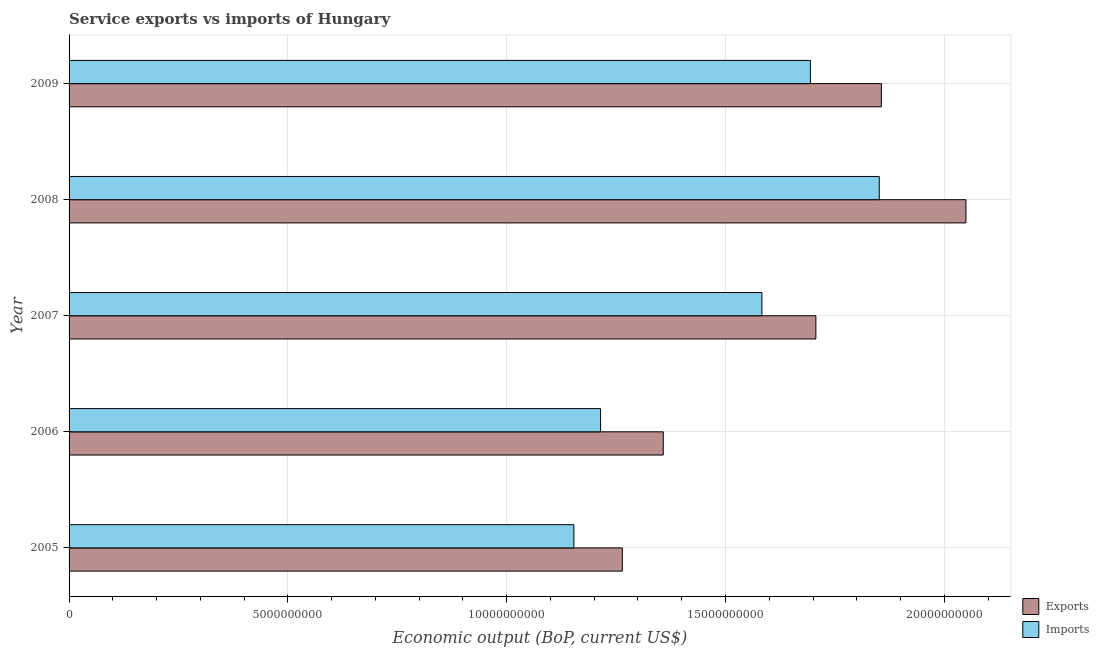How many groups of bars are there?
Give a very brief answer. 5. Are the number of bars per tick equal to the number of legend labels?
Offer a terse response. Yes. Are the number of bars on each tick of the Y-axis equal?
Your response must be concise. Yes. What is the label of the 1st group of bars from the top?
Ensure brevity in your answer.  2009. What is the amount of service imports in 2008?
Your answer should be compact. 1.85e+1. Across all years, what is the maximum amount of service imports?
Your answer should be very brief. 1.85e+1. Across all years, what is the minimum amount of service exports?
Offer a terse response. 1.26e+1. In which year was the amount of service imports maximum?
Provide a short and direct response. 2008. In which year was the amount of service exports minimum?
Ensure brevity in your answer.  2005. What is the total amount of service exports in the graph?
Your response must be concise. 8.23e+1. What is the difference between the amount of service imports in 2007 and that in 2009?
Your answer should be compact. -1.11e+09. What is the difference between the amount of service imports in 2009 and the amount of service exports in 2005?
Your answer should be compact. 4.30e+09. What is the average amount of service exports per year?
Your response must be concise. 1.65e+1. In the year 2007, what is the difference between the amount of service imports and amount of service exports?
Make the answer very short. -1.23e+09. What is the ratio of the amount of service imports in 2006 to that in 2008?
Your answer should be very brief. 0.66. Is the amount of service imports in 2006 less than that in 2009?
Keep it short and to the point. Yes. What is the difference between the highest and the second highest amount of service imports?
Provide a succinct answer. 1.57e+09. What is the difference between the highest and the lowest amount of service exports?
Provide a short and direct response. 7.85e+09. In how many years, is the amount of service exports greater than the average amount of service exports taken over all years?
Provide a short and direct response. 3. Is the sum of the amount of service imports in 2006 and 2008 greater than the maximum amount of service exports across all years?
Offer a very short reply. Yes. What does the 1st bar from the top in 2009 represents?
Keep it short and to the point. Imports. What does the 2nd bar from the bottom in 2006 represents?
Offer a terse response. Imports. How many bars are there?
Offer a terse response. 10. What is the difference between two consecutive major ticks on the X-axis?
Ensure brevity in your answer.  5.00e+09. Are the values on the major ticks of X-axis written in scientific E-notation?
Offer a very short reply. No. Does the graph contain any zero values?
Offer a terse response. No. Does the graph contain grids?
Offer a terse response. Yes. What is the title of the graph?
Your answer should be very brief. Service exports vs imports of Hungary. What is the label or title of the X-axis?
Make the answer very short. Economic output (BoP, current US$). What is the label or title of the Y-axis?
Your response must be concise. Year. What is the Economic output (BoP, current US$) of Exports in 2005?
Your answer should be very brief. 1.26e+1. What is the Economic output (BoP, current US$) in Imports in 2005?
Offer a terse response. 1.15e+1. What is the Economic output (BoP, current US$) of Exports in 2006?
Make the answer very short. 1.36e+1. What is the Economic output (BoP, current US$) in Imports in 2006?
Make the answer very short. 1.21e+1. What is the Economic output (BoP, current US$) in Exports in 2007?
Offer a very short reply. 1.71e+1. What is the Economic output (BoP, current US$) of Imports in 2007?
Offer a very short reply. 1.58e+1. What is the Economic output (BoP, current US$) in Exports in 2008?
Give a very brief answer. 2.05e+1. What is the Economic output (BoP, current US$) in Imports in 2008?
Your answer should be compact. 1.85e+1. What is the Economic output (BoP, current US$) of Exports in 2009?
Provide a short and direct response. 1.86e+1. What is the Economic output (BoP, current US$) of Imports in 2009?
Keep it short and to the point. 1.69e+1. Across all years, what is the maximum Economic output (BoP, current US$) of Exports?
Provide a succinct answer. 2.05e+1. Across all years, what is the maximum Economic output (BoP, current US$) in Imports?
Your answer should be compact. 1.85e+1. Across all years, what is the minimum Economic output (BoP, current US$) of Exports?
Provide a succinct answer. 1.26e+1. Across all years, what is the minimum Economic output (BoP, current US$) in Imports?
Offer a terse response. 1.15e+1. What is the total Economic output (BoP, current US$) in Exports in the graph?
Keep it short and to the point. 8.23e+1. What is the total Economic output (BoP, current US$) in Imports in the graph?
Offer a terse response. 7.50e+1. What is the difference between the Economic output (BoP, current US$) in Exports in 2005 and that in 2006?
Ensure brevity in your answer.  -9.35e+08. What is the difference between the Economic output (BoP, current US$) in Imports in 2005 and that in 2006?
Offer a very short reply. -6.10e+08. What is the difference between the Economic output (BoP, current US$) in Exports in 2005 and that in 2007?
Offer a terse response. -4.42e+09. What is the difference between the Economic output (BoP, current US$) of Imports in 2005 and that in 2007?
Provide a short and direct response. -4.30e+09. What is the difference between the Economic output (BoP, current US$) in Exports in 2005 and that in 2008?
Provide a short and direct response. -7.85e+09. What is the difference between the Economic output (BoP, current US$) in Imports in 2005 and that in 2008?
Your response must be concise. -6.98e+09. What is the difference between the Economic output (BoP, current US$) of Exports in 2005 and that in 2009?
Offer a terse response. -5.92e+09. What is the difference between the Economic output (BoP, current US$) in Imports in 2005 and that in 2009?
Your answer should be compact. -5.40e+09. What is the difference between the Economic output (BoP, current US$) of Exports in 2006 and that in 2007?
Your answer should be compact. -3.49e+09. What is the difference between the Economic output (BoP, current US$) of Imports in 2006 and that in 2007?
Provide a succinct answer. -3.69e+09. What is the difference between the Economic output (BoP, current US$) in Exports in 2006 and that in 2008?
Ensure brevity in your answer.  -6.92e+09. What is the difference between the Economic output (BoP, current US$) in Imports in 2006 and that in 2008?
Make the answer very short. -6.37e+09. What is the difference between the Economic output (BoP, current US$) of Exports in 2006 and that in 2009?
Keep it short and to the point. -4.98e+09. What is the difference between the Economic output (BoP, current US$) of Imports in 2006 and that in 2009?
Your answer should be compact. -4.79e+09. What is the difference between the Economic output (BoP, current US$) in Exports in 2007 and that in 2008?
Provide a short and direct response. -3.43e+09. What is the difference between the Economic output (BoP, current US$) of Imports in 2007 and that in 2008?
Ensure brevity in your answer.  -2.68e+09. What is the difference between the Economic output (BoP, current US$) of Exports in 2007 and that in 2009?
Provide a succinct answer. -1.50e+09. What is the difference between the Economic output (BoP, current US$) of Imports in 2007 and that in 2009?
Your answer should be compact. -1.11e+09. What is the difference between the Economic output (BoP, current US$) in Exports in 2008 and that in 2009?
Your answer should be very brief. 1.93e+09. What is the difference between the Economic output (BoP, current US$) in Imports in 2008 and that in 2009?
Provide a short and direct response. 1.57e+09. What is the difference between the Economic output (BoP, current US$) in Exports in 2005 and the Economic output (BoP, current US$) in Imports in 2006?
Provide a short and direct response. 4.97e+08. What is the difference between the Economic output (BoP, current US$) of Exports in 2005 and the Economic output (BoP, current US$) of Imports in 2007?
Provide a short and direct response. -3.19e+09. What is the difference between the Economic output (BoP, current US$) in Exports in 2005 and the Economic output (BoP, current US$) in Imports in 2008?
Offer a terse response. -5.87e+09. What is the difference between the Economic output (BoP, current US$) of Exports in 2005 and the Economic output (BoP, current US$) of Imports in 2009?
Your answer should be very brief. -4.30e+09. What is the difference between the Economic output (BoP, current US$) in Exports in 2006 and the Economic output (BoP, current US$) in Imports in 2007?
Provide a short and direct response. -2.25e+09. What is the difference between the Economic output (BoP, current US$) in Exports in 2006 and the Economic output (BoP, current US$) in Imports in 2008?
Offer a terse response. -4.94e+09. What is the difference between the Economic output (BoP, current US$) in Exports in 2006 and the Economic output (BoP, current US$) in Imports in 2009?
Ensure brevity in your answer.  -3.36e+09. What is the difference between the Economic output (BoP, current US$) of Exports in 2007 and the Economic output (BoP, current US$) of Imports in 2008?
Make the answer very short. -1.45e+09. What is the difference between the Economic output (BoP, current US$) in Exports in 2007 and the Economic output (BoP, current US$) in Imports in 2009?
Provide a succinct answer. 1.25e+08. What is the difference between the Economic output (BoP, current US$) in Exports in 2008 and the Economic output (BoP, current US$) in Imports in 2009?
Provide a short and direct response. 3.55e+09. What is the average Economic output (BoP, current US$) of Exports per year?
Your answer should be very brief. 1.65e+1. What is the average Economic output (BoP, current US$) in Imports per year?
Offer a terse response. 1.50e+1. In the year 2005, what is the difference between the Economic output (BoP, current US$) of Exports and Economic output (BoP, current US$) of Imports?
Your answer should be compact. 1.11e+09. In the year 2006, what is the difference between the Economic output (BoP, current US$) of Exports and Economic output (BoP, current US$) of Imports?
Offer a terse response. 1.43e+09. In the year 2007, what is the difference between the Economic output (BoP, current US$) of Exports and Economic output (BoP, current US$) of Imports?
Your response must be concise. 1.23e+09. In the year 2008, what is the difference between the Economic output (BoP, current US$) in Exports and Economic output (BoP, current US$) in Imports?
Your answer should be very brief. 1.98e+09. In the year 2009, what is the difference between the Economic output (BoP, current US$) in Exports and Economic output (BoP, current US$) in Imports?
Your answer should be very brief. 1.62e+09. What is the ratio of the Economic output (BoP, current US$) in Exports in 2005 to that in 2006?
Your response must be concise. 0.93. What is the ratio of the Economic output (BoP, current US$) of Imports in 2005 to that in 2006?
Provide a short and direct response. 0.95. What is the ratio of the Economic output (BoP, current US$) of Exports in 2005 to that in 2007?
Your response must be concise. 0.74. What is the ratio of the Economic output (BoP, current US$) in Imports in 2005 to that in 2007?
Keep it short and to the point. 0.73. What is the ratio of the Economic output (BoP, current US$) of Exports in 2005 to that in 2008?
Provide a short and direct response. 0.62. What is the ratio of the Economic output (BoP, current US$) in Imports in 2005 to that in 2008?
Your response must be concise. 0.62. What is the ratio of the Economic output (BoP, current US$) in Exports in 2005 to that in 2009?
Provide a short and direct response. 0.68. What is the ratio of the Economic output (BoP, current US$) in Imports in 2005 to that in 2009?
Ensure brevity in your answer.  0.68. What is the ratio of the Economic output (BoP, current US$) of Exports in 2006 to that in 2007?
Provide a short and direct response. 0.8. What is the ratio of the Economic output (BoP, current US$) in Imports in 2006 to that in 2007?
Provide a short and direct response. 0.77. What is the ratio of the Economic output (BoP, current US$) of Exports in 2006 to that in 2008?
Give a very brief answer. 0.66. What is the ratio of the Economic output (BoP, current US$) of Imports in 2006 to that in 2008?
Offer a terse response. 0.66. What is the ratio of the Economic output (BoP, current US$) of Exports in 2006 to that in 2009?
Your response must be concise. 0.73. What is the ratio of the Economic output (BoP, current US$) in Imports in 2006 to that in 2009?
Keep it short and to the point. 0.72. What is the ratio of the Economic output (BoP, current US$) in Exports in 2007 to that in 2008?
Offer a terse response. 0.83. What is the ratio of the Economic output (BoP, current US$) in Imports in 2007 to that in 2008?
Offer a very short reply. 0.86. What is the ratio of the Economic output (BoP, current US$) in Exports in 2007 to that in 2009?
Make the answer very short. 0.92. What is the ratio of the Economic output (BoP, current US$) in Imports in 2007 to that in 2009?
Your response must be concise. 0.93. What is the ratio of the Economic output (BoP, current US$) in Exports in 2008 to that in 2009?
Provide a succinct answer. 1.1. What is the ratio of the Economic output (BoP, current US$) in Imports in 2008 to that in 2009?
Keep it short and to the point. 1.09. What is the difference between the highest and the second highest Economic output (BoP, current US$) in Exports?
Give a very brief answer. 1.93e+09. What is the difference between the highest and the second highest Economic output (BoP, current US$) of Imports?
Ensure brevity in your answer.  1.57e+09. What is the difference between the highest and the lowest Economic output (BoP, current US$) of Exports?
Your answer should be very brief. 7.85e+09. What is the difference between the highest and the lowest Economic output (BoP, current US$) of Imports?
Offer a very short reply. 6.98e+09. 